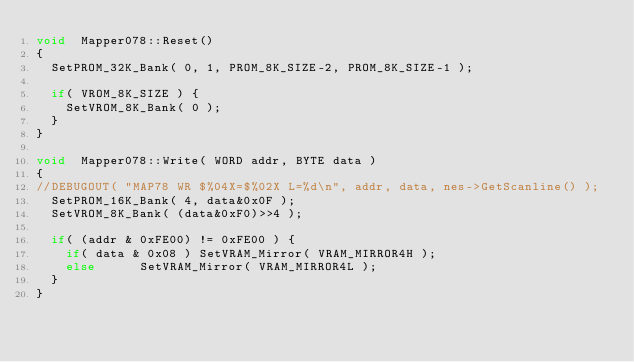<code> <loc_0><loc_0><loc_500><loc_500><_C++_>void	Mapper078::Reset()
{
	SetPROM_32K_Bank( 0, 1, PROM_8K_SIZE-2, PROM_8K_SIZE-1 );

	if( VROM_8K_SIZE ) {
		SetVROM_8K_Bank( 0 );
	}
}

void	Mapper078::Write( WORD addr, BYTE data )
{
//DEBUGOUT( "MAP78 WR $%04X=$%02X L=%d\n", addr, data, nes->GetScanline() );
	SetPROM_16K_Bank( 4, data&0x0F );
	SetVROM_8K_Bank( (data&0xF0)>>4 );

	if( (addr & 0xFE00) != 0xFE00 ) {
		if( data & 0x08 ) SetVRAM_Mirror( VRAM_MIRROR4H );
		else		  SetVRAM_Mirror( VRAM_MIRROR4L );
	}
}
</code> 